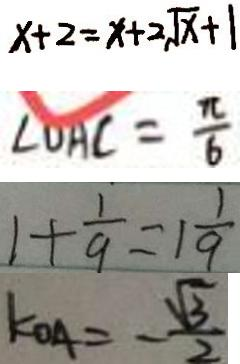<formula> <loc_0><loc_0><loc_500><loc_500>x + 2 = x + 2 \sqrt { x } + 1 
 \angle D A C = \frac { \pi } { 6 } 
 1 + \frac { 1 } { 9 } = 1 \frac { 1 } { 9 } 
 k _ { O A } = - \frac { \sqrt { 3 } } { 2 }</formula> 